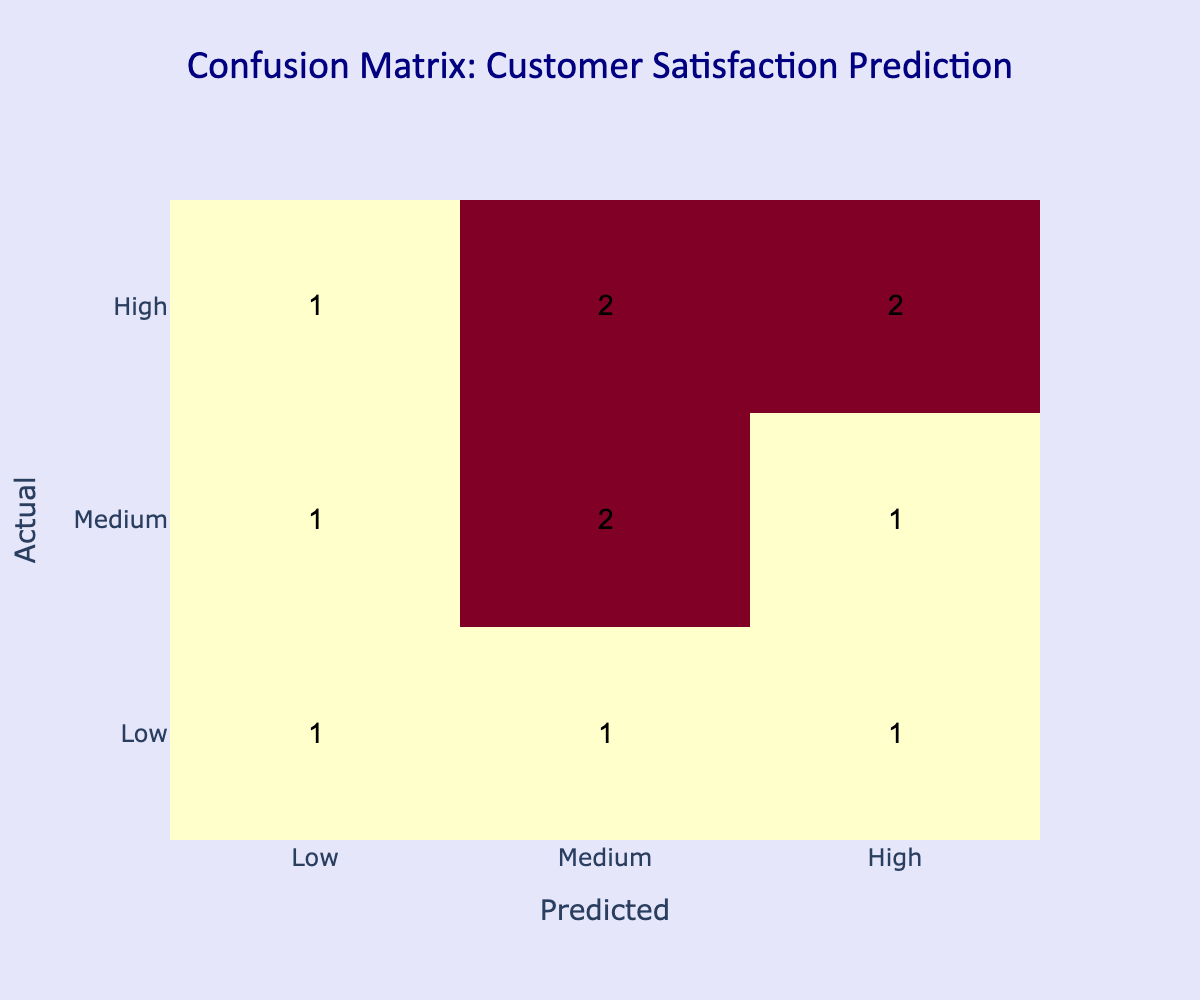What is the count of times 'High' actual satisfaction was predicted as 'High'? In the confusion matrix, I need to look at the intersection of the 'High' actual satisfaction row and the 'High' predicted satisfaction column. This cell shows a value of 3, which indicates that 'High' satisfaction was predicted correctly 3 times.
Answer: 3 What is the total number of 'Medium' actual satisfaction predictions? To find the total number of 'Medium' actual satisfaction predictions, I add the values from the 'Medium' row: 'High' (1), 'Medium' (3), and 'Low' (1). Summing these values gives me 5.
Answer: 5 Number of times 'Low' actual satisfaction was incorrectly predicted? The times when 'Low' satisfaction was predicted incorrectly can be found by adding the number of times 'Low' is predicted as 'Medium' (1) and 'High' (1) for 'Low' actual satisfaction. Thus, the total is 1 + 1 = 2.
Answer: 2 What is the ratio of 'High' actual satisfaction predictions to total predictions? The count of 'High' predictions is 3 for 'High', 1 for 'Medium', and 1 for 'Low', totaling 5 actual 'High' satisfactions in the 'Actual' row. The total number of predictions is 12 (sum of all cells). The ratio is calculated as 5/12.
Answer: 5/12 Is the model better at predicting 'High' satisfaction than 'Low' satisfaction? To determine this, I'm comparing the correct predictions for 'High' (3) and 'Low' (3). They are equal, so the model is not better at predicting one over the other.
Answer: No How many total predictions were made for 'Medium' satisfaction? I check the 'Medium' column to find values from all the rows: 'Low' (1), 'Medium' (3), and 'High' (2). Summing these values gives me 1 + 3 + 2 = 6.
Answer: 6 What is the difference between the number of times 'High' was predicted and 'Low' predicted? First, I note the counts for 'High' predicted (3 + 1 + 2 = 6) and 'Low' predicted (1 + 2 + 3 = 6) from the matrix and take the difference: 6 - 6 = 0. So the difference is 0.
Answer: 0 What percentage of predictions were for 'Medium' satisfaction? There are 6 'Medium' predictions out of a total of 12 predictions. To find the percentage, I calculate (6/12) * 100 = 50%.
Answer: 50% How many times did the model predict 'Low' satisfaction for an actual 'Medium' satisfaction? Looking at the confusion matrix, the count of 'Low' predictions for 'Medium' actual satisfaction is 1. Therefore, it predicted 'Low' for actual 'Medium' once.
Answer: 1 